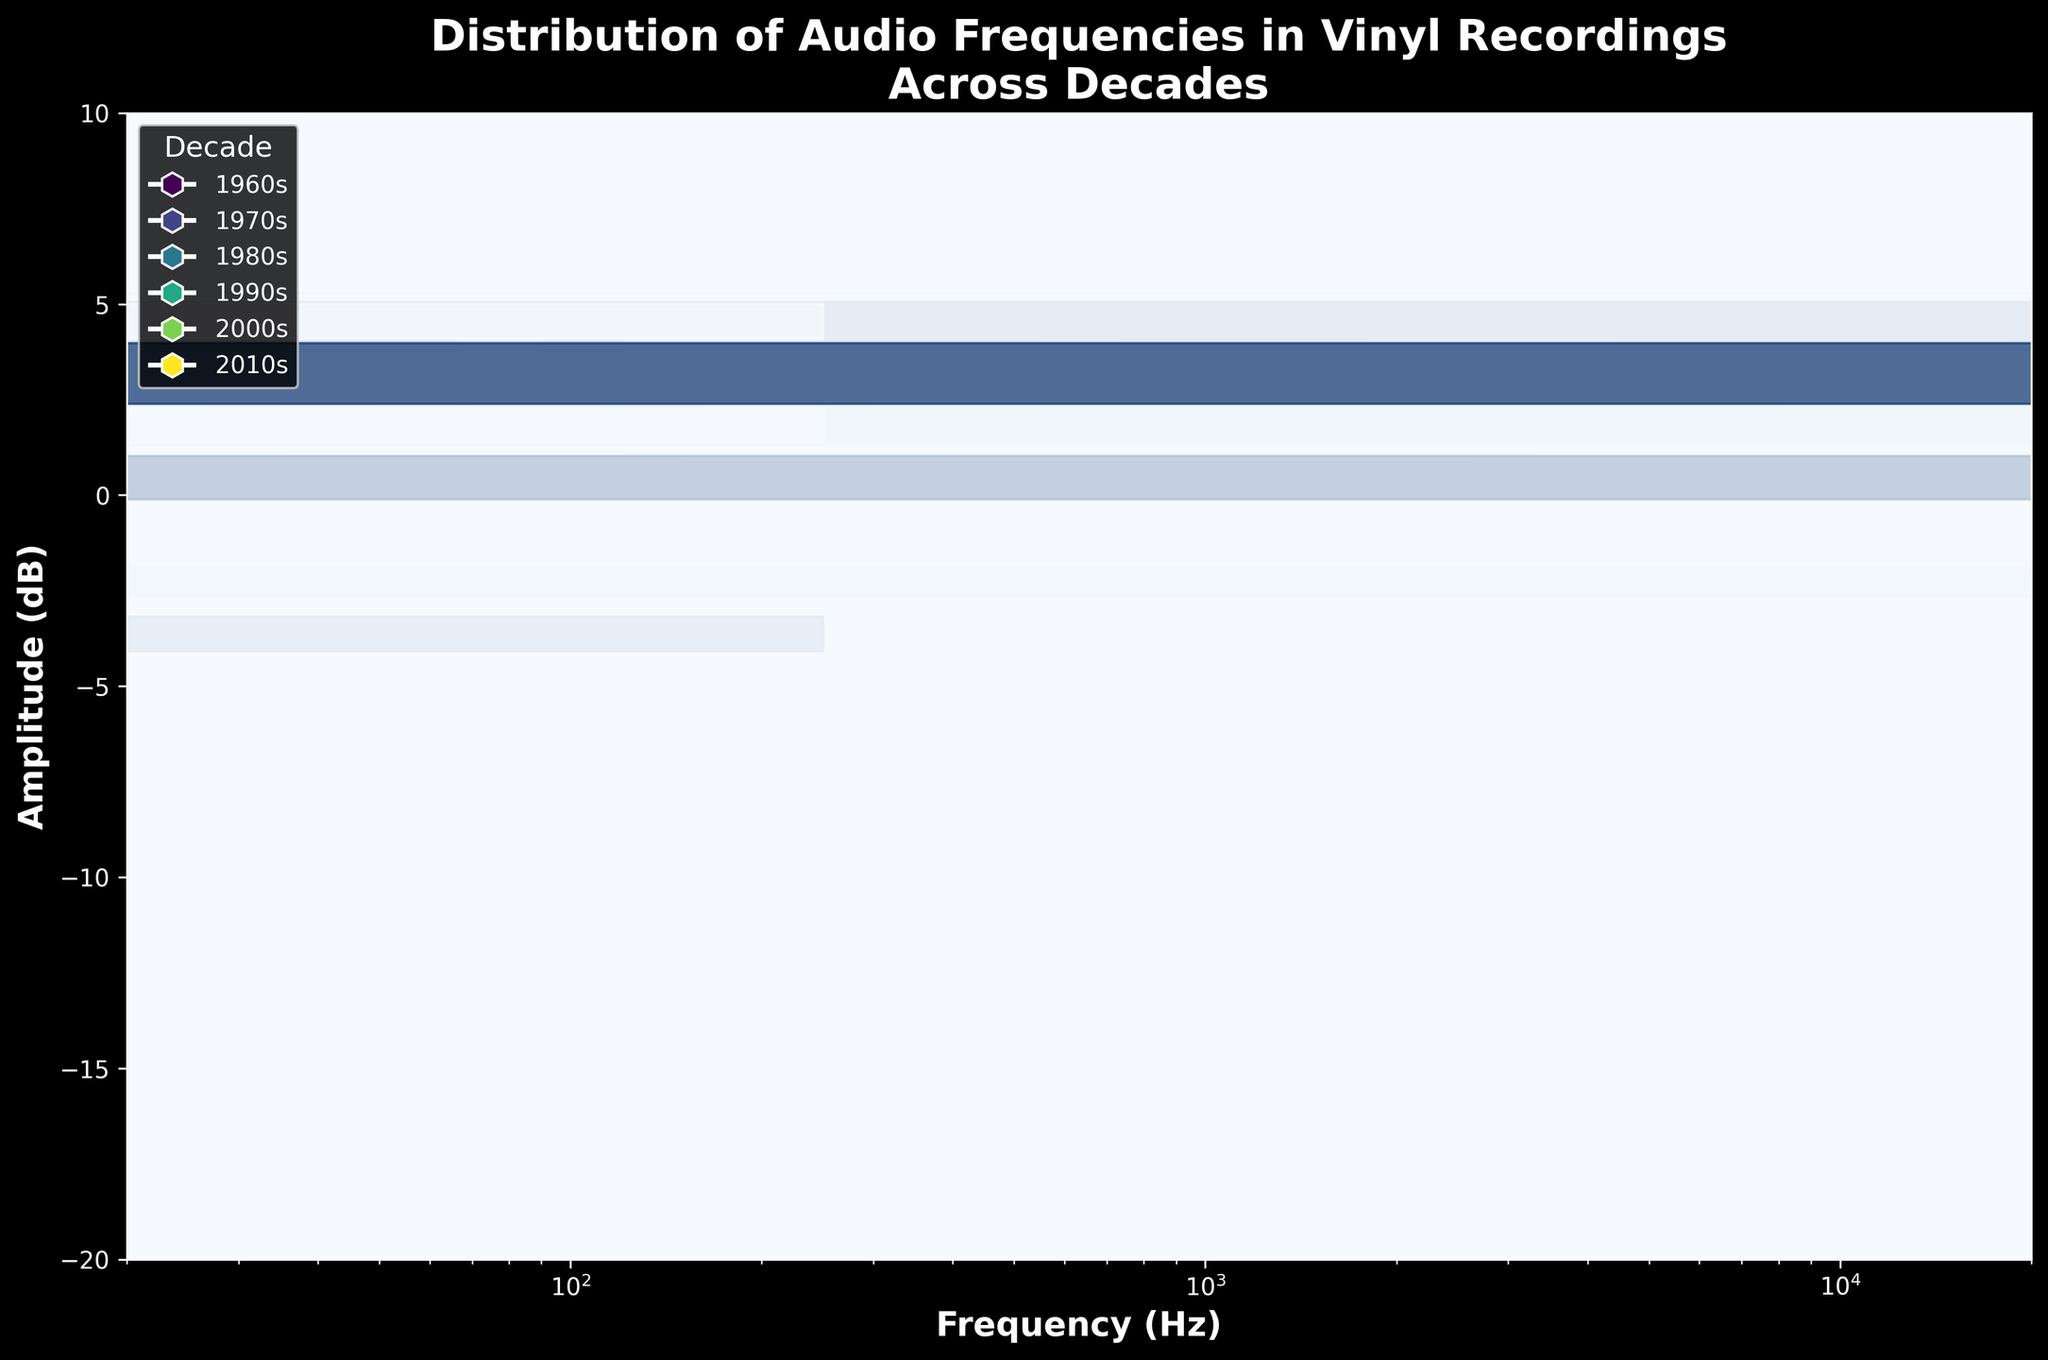What does the title of the hexbin plot tell us? The title reads "Distribution of Audio Frequencies in Vinyl Recordings Across Decades," indicating that the plot shows how audio frequencies' amplitudes vary across different decades.
Answer: Distribution of Audio Frequencies in Vinyl Recordings Across Decades What is the range of the x-axis? The x-axis, labeled "Frequency (Hz)," ranges from 20 to 20000 Hz.
Answer: 20 to 20000 Hz Which decade shows the highest amplitude in any of the frequencies? The 2010s show the highest amplitude, with a point at 1000 Hz reaching 6 dB.
Answer: 2010s What is the general trend in amplitude for lower frequencies (near 50 Hz) across the decades? Starting from the 1960s to the 2010s, the amplitude of lower frequencies (50 Hz) steadily increases from -15 dB to -4 dB.
Answer: Increasing trend Is there a decade where the majority of frequencies have negative amplitudes? Yes, the 1960s have most frequency points with negative amplitudes, spanning from -15 dB to 0 dB.
Answer: 1960s What frequency range tends to have the highest amplitude values, based on the plot? Frequencies around 500 Hz and 1000 Hz tend to have the highest amplitude values in the plot.
Answer: 500 Hz and 1000 Hz Compare the amplitude of 10000 Hz frequency in the 1960s and the 2000s. In the 1960s, the amplitude at 10000 Hz is -12 dB, while in the 2000s it is -4 dB, showing an increase over time.
Answer: -12 dB in 1960s, -4 dB in 2000s What observation can be made about the amplitude values in the 2010s? The 2010s show a general upward shift in amplitude values across frequencies, with most data points clustering around higher dB levels compared to previous decades.
Answer: Upward shift in amplitude How does the amplitude at 5000 Hz change from the 1960s to the 2010s? In the 1960s, the amplitude at 5000 Hz is -8 dB, and it increases to 1 dB by the 2010s.
Answer: From -8 dB to 1 dB What decade shows a significant increase in amplitude values across all frequencies compared to the previous decades? The 2010s show a significant increase in amplitude values across all frequencies compared to previous decades.
Answer: 2010s 